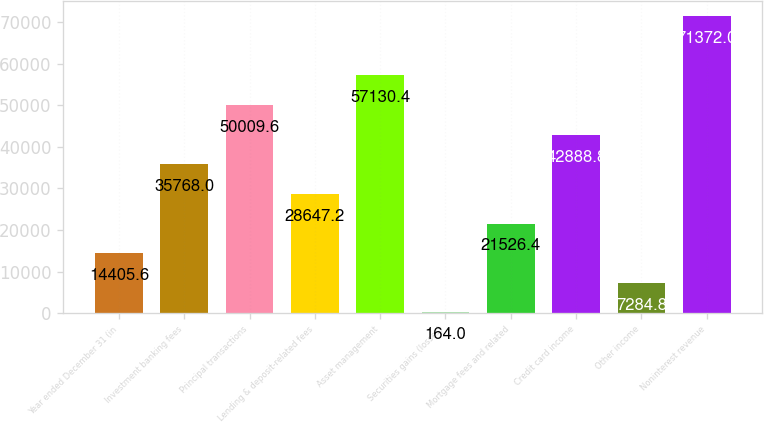Convert chart to OTSL. <chart><loc_0><loc_0><loc_500><loc_500><bar_chart><fcel>Year ended December 31 (in<fcel>Investment banking fees<fcel>Principal transactions<fcel>Lending & deposit-related fees<fcel>Asset management<fcel>Securities gains (losses)<fcel>Mortgage fees and related<fcel>Credit card income<fcel>Other income<fcel>Noninterest revenue<nl><fcel>14405.6<fcel>35768<fcel>50009.6<fcel>28647.2<fcel>57130.4<fcel>164<fcel>21526.4<fcel>42888.8<fcel>7284.8<fcel>71372<nl></chart> 